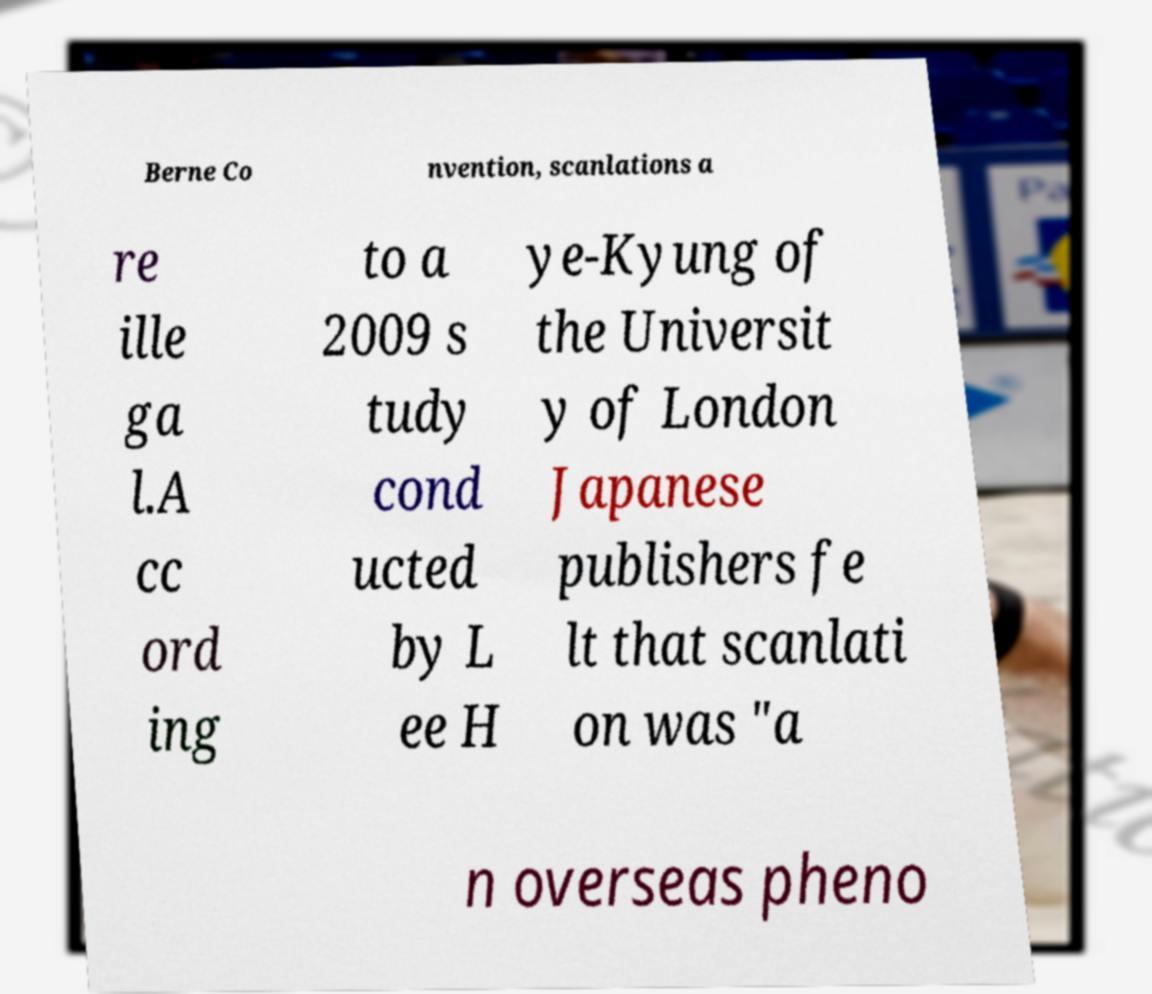What messages or text are displayed in this image? I need them in a readable, typed format. Berne Co nvention, scanlations a re ille ga l.A cc ord ing to a 2009 s tudy cond ucted by L ee H ye-Kyung of the Universit y of London Japanese publishers fe lt that scanlati on was "a n overseas pheno 